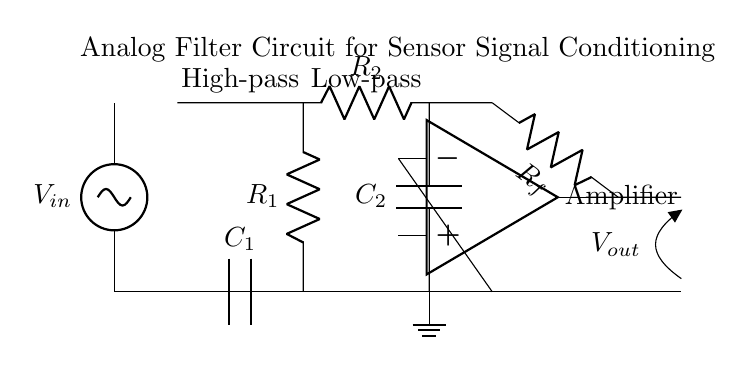What is the function of C1 in this circuit? C1 is a capacitor used in the high-pass filter configuration. It allows high-frequency signals to pass through while blocking low-frequency signals.
Answer: High-pass filter What type of filter is implemented by C2? C2 is a capacitor used in the low-pass filter configuration which allows low-frequency signals to pass through while blocking high-frequency signals.
Answer: Low-pass filter What is the role of the operational amplifier in this circuit? The operational amplifier amplifies the difference in voltage between its inputs, providing gain to the filtered signal. It helps to strengthen the output signal for further processing.
Answer: Amplification What is the expected output voltage of this circuit if V_in is 10V? The output voltage would be influenced by the gain set by the resistor R_f and the configuration of the op-amp. For instance, if R_f and the related resistors are equal, the output could also be around 10V, depending on additional factors like the input signal frequency.
Answer: Approximately 10V What components are used in the feedback loop of the amplifier? The feedback loop consists of the resistor R_f, which connects the output of the op-amp back to its non-inverting input, thereby controlling the gain.
Answer: Resistor Which two components set the cutoff frequencies for the filters? The cutoff frequencies for the high-pass and low-pass filters are set by the capacitor and resistor pairs, specifically C1 and R1 for the high-pass filter, and C2 and R2 for the low-pass filter.
Answer: C1, R1, C2, R2 